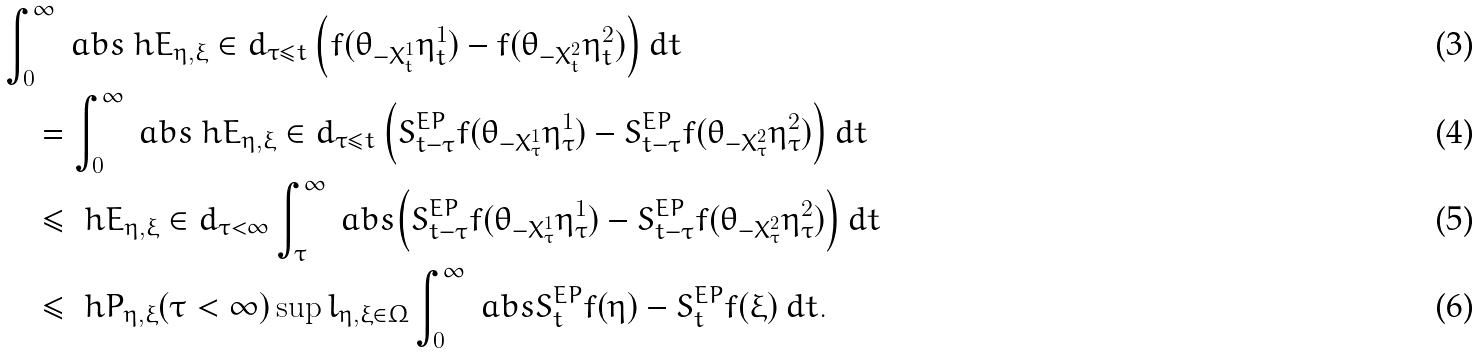Convert formula to latex. <formula><loc_0><loc_0><loc_500><loc_500>& \int _ { 0 } ^ { \infty } \ a b s { \ h E _ { \eta , \xi } \in d _ { \tau \leq t } \left ( f ( \theta _ { - X _ { t } ^ { 1 } } \eta _ { t } ^ { 1 } ) - f ( \theta _ { - X _ { t } ^ { 2 } } \eta _ { t } ^ { 2 } ) \right ) } \, d t \\ & \quad = \int _ { 0 } ^ { \infty } \ a b s { \ h E _ { \eta , \xi } \in d _ { \tau \leq t } \left ( S _ { t - \tau } ^ { E P } f ( \theta _ { - X _ { \tau } ^ { 1 } } \eta _ { \tau } ^ { 1 } ) - S _ { t - \tau } ^ { E P } f ( \theta _ { - X _ { \tau } ^ { 2 } } \eta _ { \tau } ^ { 2 } ) \right ) } \, d t \\ & \quad \leq \ h E _ { \eta , \xi } \in d _ { \tau < \infty } \int _ { \tau } ^ { \infty } \ a b s { \left ( S _ { t - \tau } ^ { E P } f ( \theta _ { - X _ { \tau } ^ { 1 } } \eta _ { \tau } ^ { 1 } ) - S _ { t - \tau } ^ { E P } f ( \theta _ { - X _ { \tau } ^ { 2 } } \eta _ { \tau } ^ { 2 } ) \right ) } \, d t \\ & \quad \leq \ h P _ { \eta , \xi } ( \tau < \infty ) \sup l _ { \eta , \xi \in \Omega } \int _ { 0 } ^ { \infty } \ a b s { S _ { t } ^ { E P } f ( \eta ) - S _ { t } ^ { E P } f ( \xi ) } \, d t .</formula> 